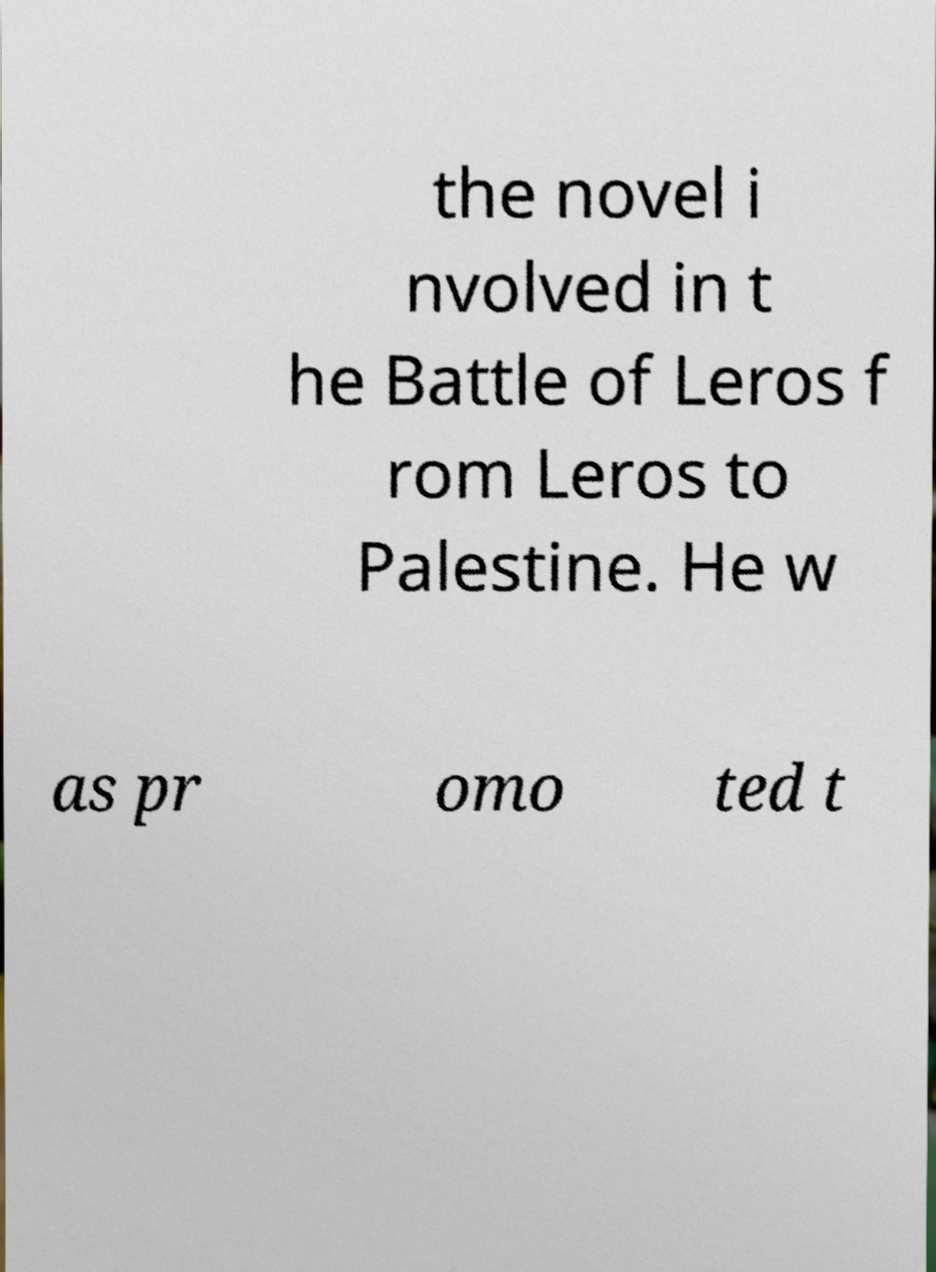Could you extract and type out the text from this image? the novel i nvolved in t he Battle of Leros f rom Leros to Palestine. He w as pr omo ted t 